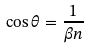<formula> <loc_0><loc_0><loc_500><loc_500>\cos \theta = \frac { 1 } { \beta n }</formula> 